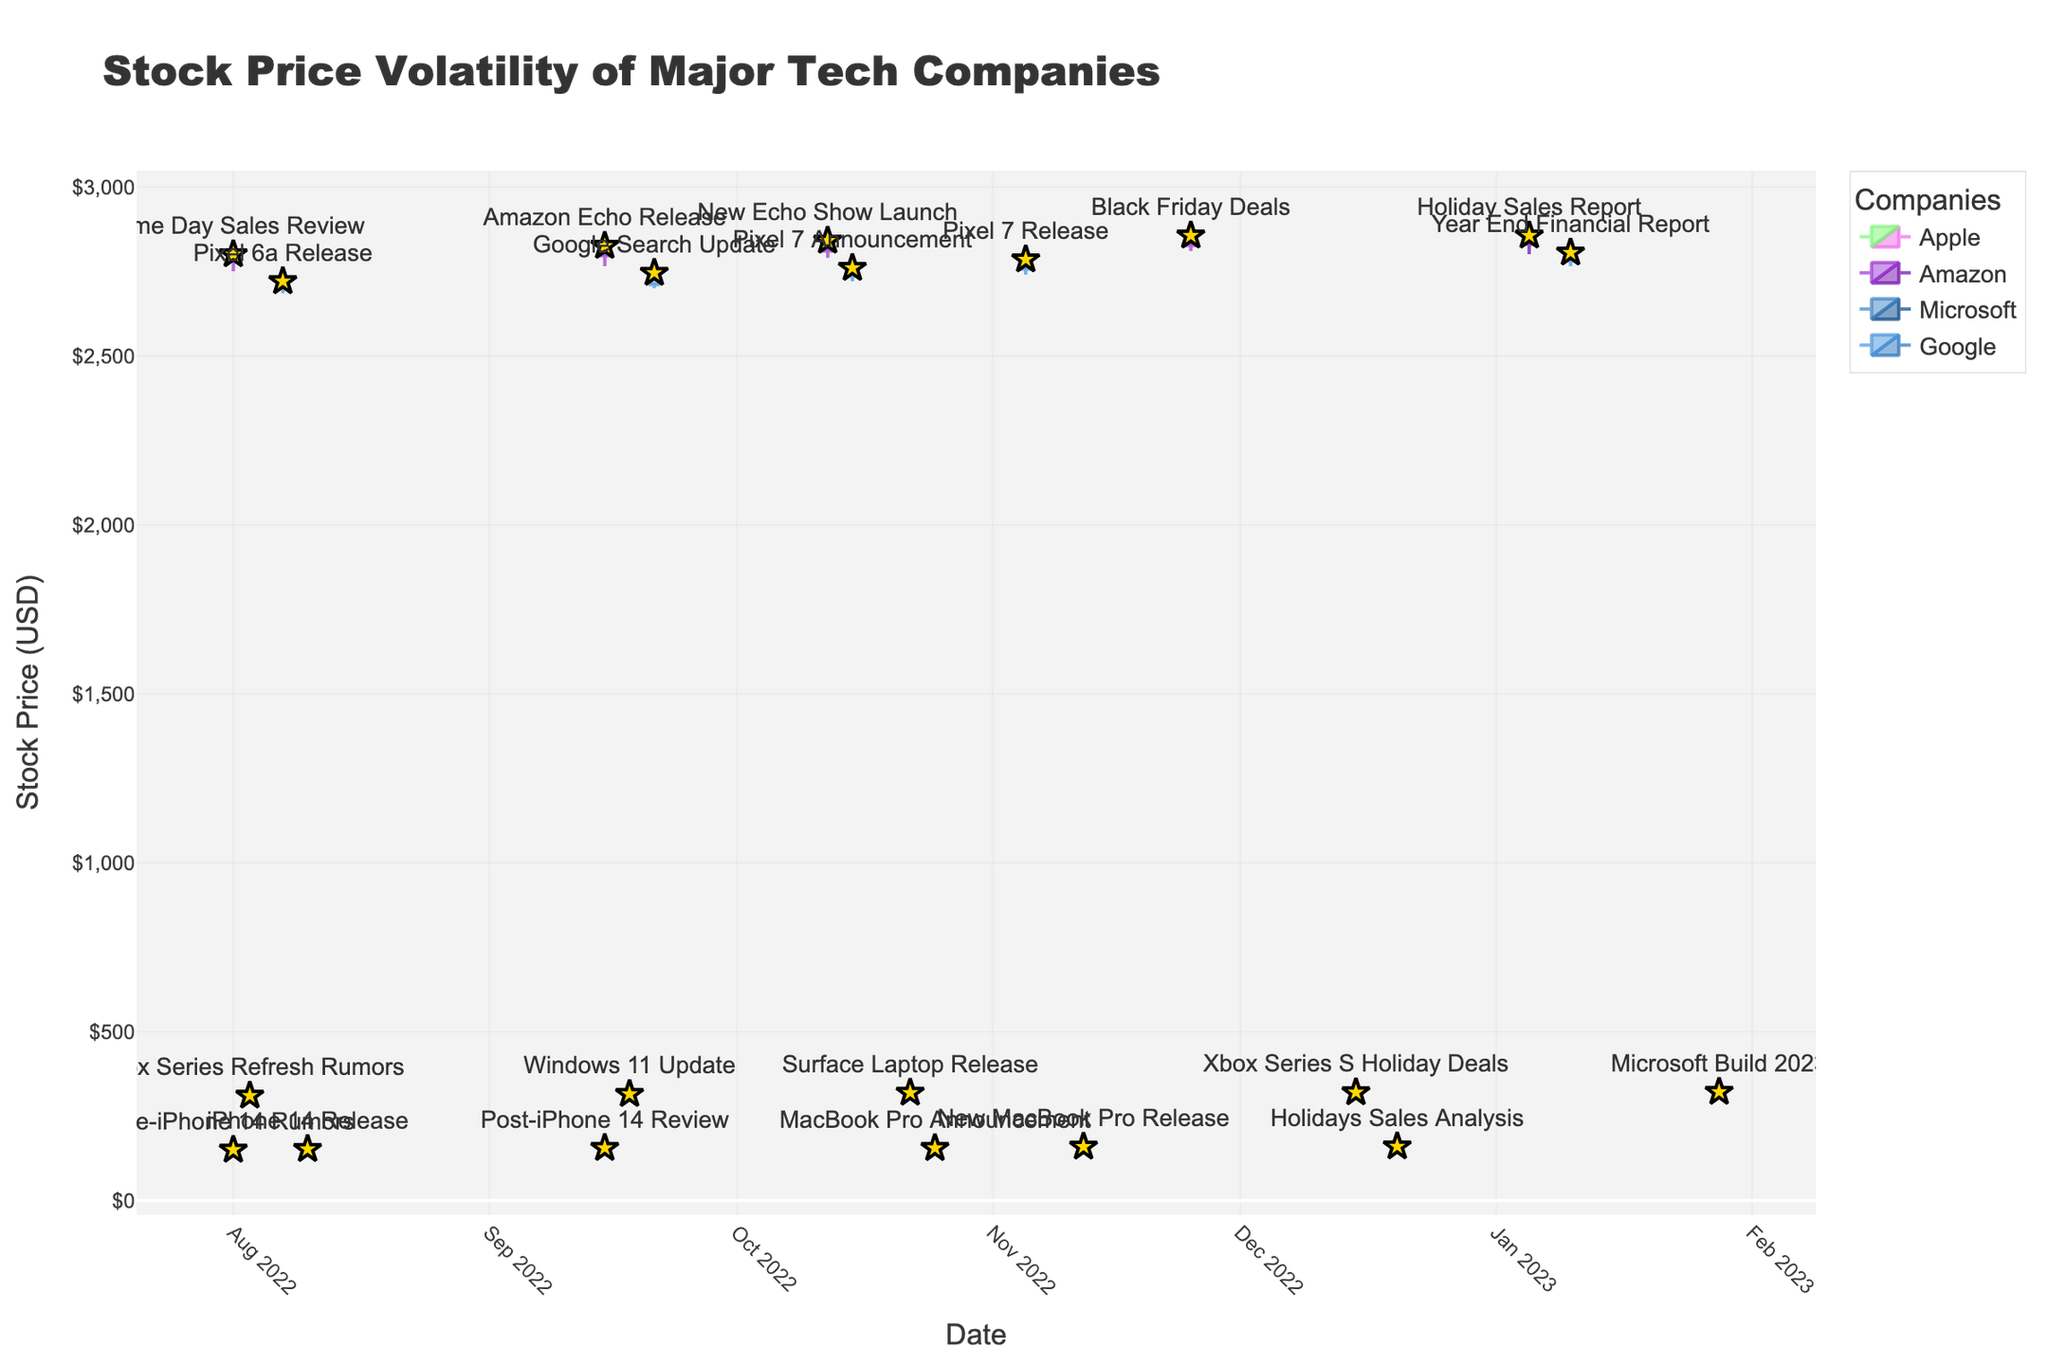Which company's stock price had the highest peak in the past year? To determine which company's stock price had the highest peak, look at the highest candlestick within the entire plot. Compare the highs and find the maximum one. Amazon's stock had the highest peak at around $2855.90 on November 25, 2022.
Answer: Amazon What was the difference between the highest and lowest closing price for Apple over the past year? To find the difference, identify the highest and lowest closing prices for Apple in the candlestick plot. The highest closing price was $159.50, and the lowest was $148.50. The difference is $159.50 - $148.50 = $11.00.
Answer: $11.00 How did the release of the Pixel 7 affect Google's stock price? Look at the candlestick on the date of the Pixel 7 Release (November 5, 2022). Notice the movement from the previous date. The stock showed a slight increase, closing at $2780.50 compared to $2755.60 on October 15, 2022.
Answer: Slight increase Which company had the highest trading volume during a significant product release event? Identify the highest volume values in the plot associated with product release events. Compare these volumes among companies. Apple's New MacBook Pro Release on November 12, 2022, had the highest volume at 27,890,000.
Answer: Apple How did Apple's stock price react immediately after the iPhone 14 release on August 10, 2022? Look at the candlestick for Apple on August 10, 2022, and the subsequent candlestick. Apple's stock price increased from $148.50 (close on August 1) to $151.00 on August 10. Following days showed a further increase to $154.60 on September 15, 2022.
Answer: Increased What is the average closing price of Microsoft's stock over the displayed period? Compute the average by summing Microsoft's closing prices and then dividing by the number of data points. (307.10 + 313.50 + 316.45 + 317.80 + 320.40) / 5 = 315.45
Answer: 315.45 Which significant event corresponded with the largest increase in Amazon's stock price? Compare the increase in closing prices around significant events for Amazon. The largest increase occurred around the New Echo Show Launch on October 12, 2022, where the closing price went from $2809.60 on September 15 to $2825.30.
Answer: New Echo Show Launch Was there any notable stock price decline for Google after a major announcement? Inspect the candlesticks following significant announcements for Google, noting any declines. The Google Search Update on September 21, 2022, didn't show a notable decline, indicating stable or positive responses during announcements.
Answer: No notable decline Comparing the stock price movements, which company's stock showed the most volatility in response to product releases? Review the candlesticks surrounding product releases for each company, focusing on the range between the highest and lowest prices. Apple and Amazon showed notable volatility, but Apple's events (e.g., iPhone 14) had more evident fluctuations.
Answer: Apple How did Microsoft's stock price close on the day of the 'Microsoft Build 2023' event? Look at the candlestick for the date corresponding to 'Microsoft Build 2023' on January 28, 2023. The stock closed at $320.40.
Answer: $320.40 